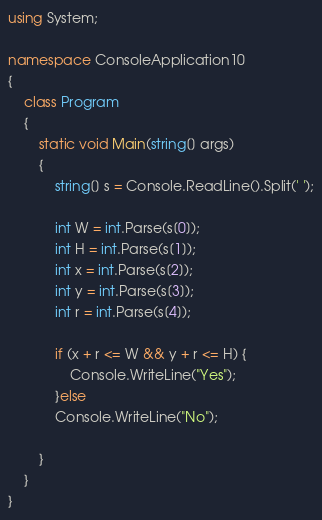<code> <loc_0><loc_0><loc_500><loc_500><_C#_>using System;

namespace ConsoleApplication10
{
    class Program
    {
        static void Main(string[] args)
        {
            string[] s = Console.ReadLine().Split(' ');

            int W = int.Parse(s[0]);
            int H = int.Parse(s[1]);
            int x = int.Parse(s[2]);
            int y = int.Parse(s[3]);
            int r = int.Parse(s[4]);

            if (x + r <= W && y + r <= H) {
                Console.WriteLine("Yes");
            }else
            Console.WriteLine("No");
            
        }
    }
}</code> 